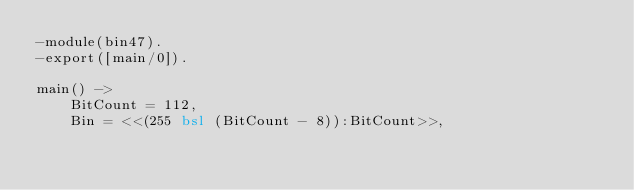Convert code to text. <code><loc_0><loc_0><loc_500><loc_500><_Erlang_>-module(bin47).
-export([main/0]).

main() ->
	BitCount = 112,
	Bin = <<(255 bsl (BitCount - 8)):BitCount>>,</code> 